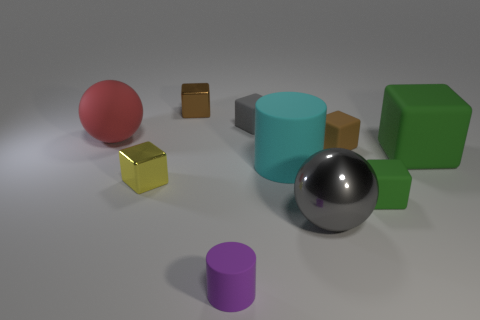Subtract all tiny gray matte cubes. How many cubes are left? 5 Subtract all gray blocks. How many blocks are left? 5 Subtract 1 blocks. How many blocks are left? 5 Subtract all brown cubes. Subtract all gray balls. How many cubes are left? 4 Subtract all cubes. How many objects are left? 4 Subtract all brown things. Subtract all small purple rubber cylinders. How many objects are left? 7 Add 9 big green rubber objects. How many big green rubber objects are left? 10 Add 1 metal cubes. How many metal cubes exist? 3 Subtract 0 red blocks. How many objects are left? 10 